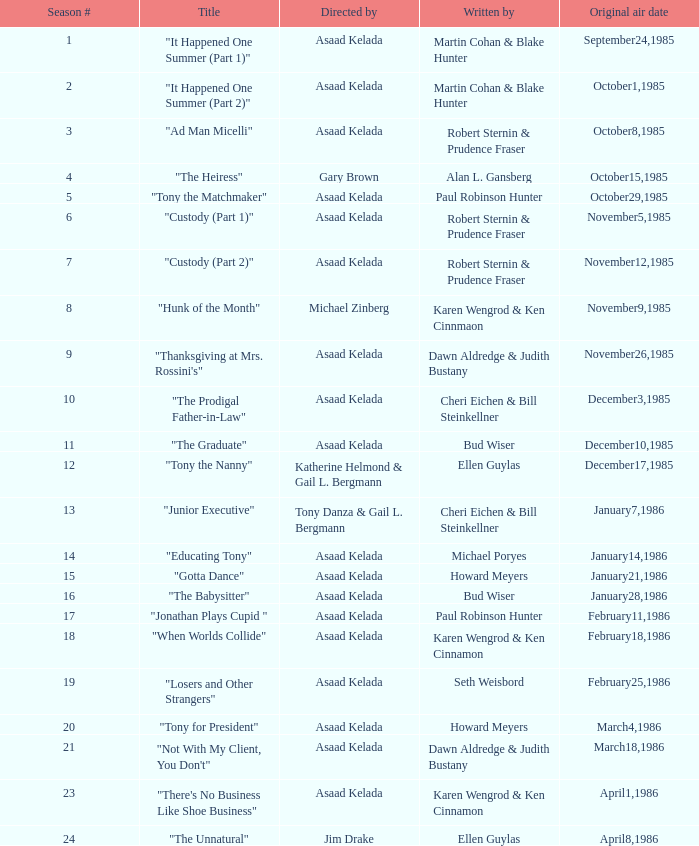Who were the authors of series episode #25? Robert Sternin & Prudence Fraser. 